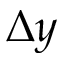Convert formula to latex. <formula><loc_0><loc_0><loc_500><loc_500>\Delta y</formula> 